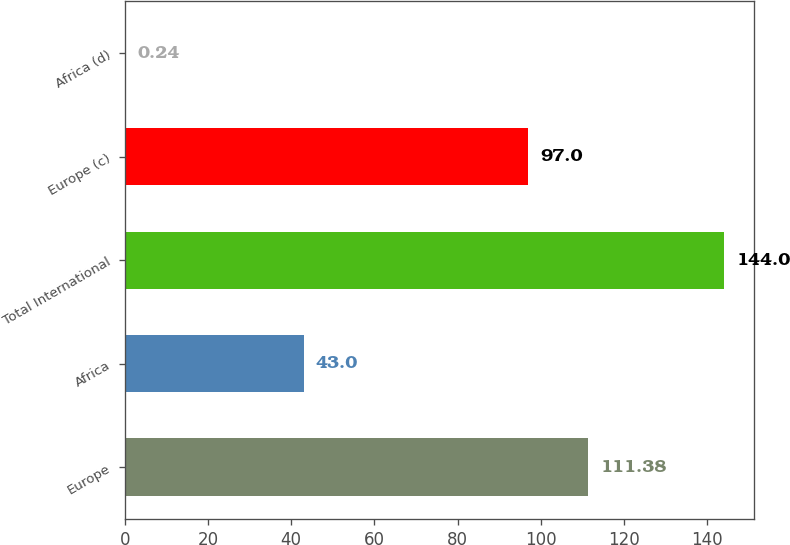Convert chart to OTSL. <chart><loc_0><loc_0><loc_500><loc_500><bar_chart><fcel>Europe<fcel>Africa<fcel>Total International<fcel>Europe (c)<fcel>Africa (d)<nl><fcel>111.38<fcel>43<fcel>144<fcel>97<fcel>0.24<nl></chart> 